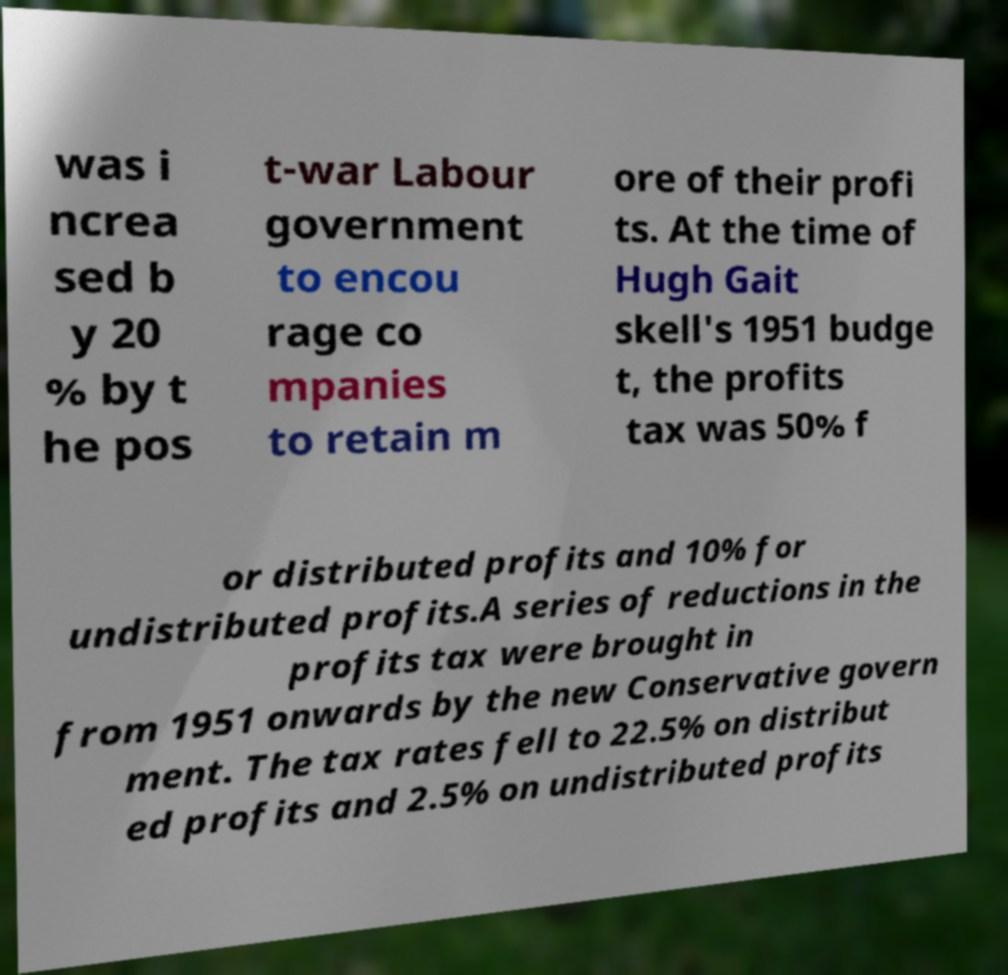For documentation purposes, I need the text within this image transcribed. Could you provide that? was i ncrea sed b y 20 % by t he pos t-war Labour government to encou rage co mpanies to retain m ore of their profi ts. At the time of Hugh Gait skell's 1951 budge t, the profits tax was 50% f or distributed profits and 10% for undistributed profits.A series of reductions in the profits tax were brought in from 1951 onwards by the new Conservative govern ment. The tax rates fell to 22.5% on distribut ed profits and 2.5% on undistributed profits 